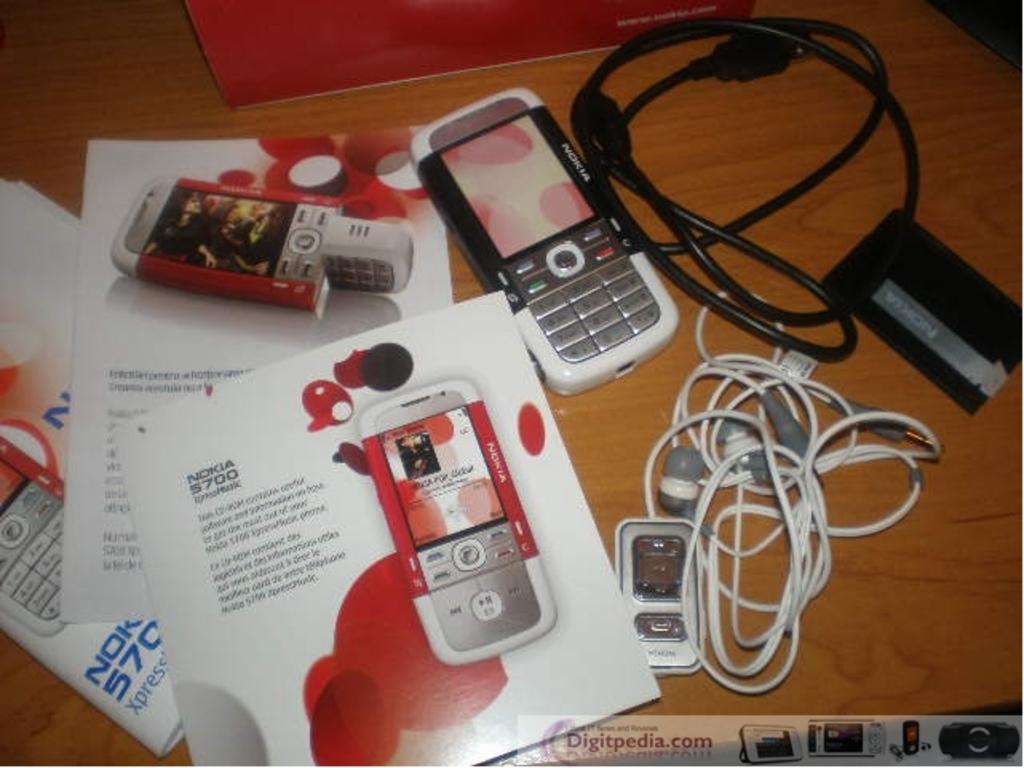What brand of phone is this?
Offer a terse response. Nokia. What kind of phone is listed?
Your answer should be very brief. Nokia 5700. 